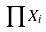Convert formula to latex. <formula><loc_0><loc_0><loc_500><loc_500>\prod X _ { i }</formula> 